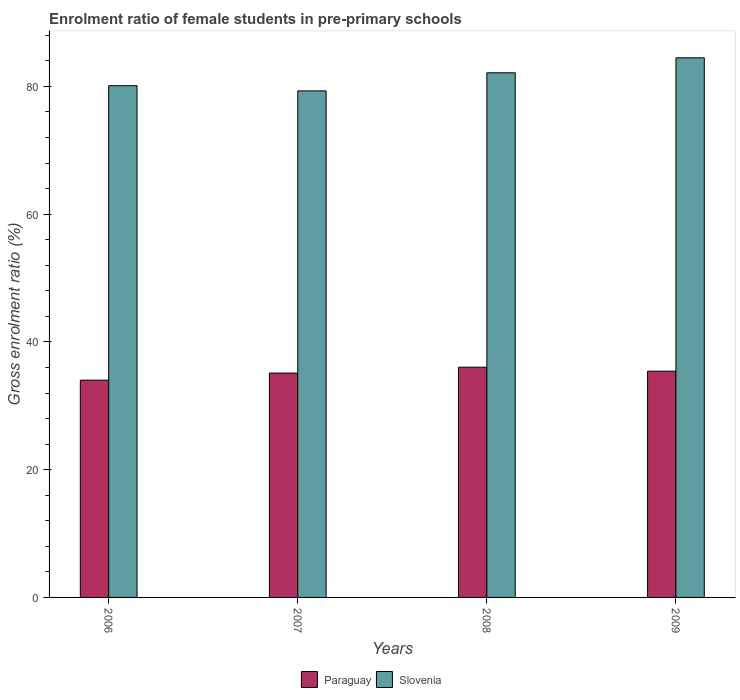How many different coloured bars are there?
Give a very brief answer. 2. Are the number of bars per tick equal to the number of legend labels?
Give a very brief answer. Yes. Are the number of bars on each tick of the X-axis equal?
Provide a short and direct response. Yes. In how many cases, is the number of bars for a given year not equal to the number of legend labels?
Provide a short and direct response. 0. What is the enrolment ratio of female students in pre-primary schools in Slovenia in 2008?
Your answer should be very brief. 82.13. Across all years, what is the maximum enrolment ratio of female students in pre-primary schools in Slovenia?
Your answer should be very brief. 84.48. Across all years, what is the minimum enrolment ratio of female students in pre-primary schools in Paraguay?
Offer a terse response. 34.02. What is the total enrolment ratio of female students in pre-primary schools in Paraguay in the graph?
Keep it short and to the point. 140.6. What is the difference between the enrolment ratio of female students in pre-primary schools in Slovenia in 2007 and that in 2008?
Your answer should be very brief. -2.83. What is the difference between the enrolment ratio of female students in pre-primary schools in Paraguay in 2007 and the enrolment ratio of female students in pre-primary schools in Slovenia in 2006?
Offer a very short reply. -44.99. What is the average enrolment ratio of female students in pre-primary schools in Slovenia per year?
Your response must be concise. 81.51. In the year 2008, what is the difference between the enrolment ratio of female students in pre-primary schools in Slovenia and enrolment ratio of female students in pre-primary schools in Paraguay?
Make the answer very short. 46.09. In how many years, is the enrolment ratio of female students in pre-primary schools in Paraguay greater than 40 %?
Your answer should be compact. 0. What is the ratio of the enrolment ratio of female students in pre-primary schools in Paraguay in 2008 to that in 2009?
Your response must be concise. 1.02. Is the enrolment ratio of female students in pre-primary schools in Slovenia in 2007 less than that in 2009?
Ensure brevity in your answer.  Yes. Is the difference between the enrolment ratio of female students in pre-primary schools in Slovenia in 2006 and 2009 greater than the difference between the enrolment ratio of female students in pre-primary schools in Paraguay in 2006 and 2009?
Offer a terse response. No. What is the difference between the highest and the second highest enrolment ratio of female students in pre-primary schools in Paraguay?
Give a very brief answer. 0.62. What is the difference between the highest and the lowest enrolment ratio of female students in pre-primary schools in Paraguay?
Give a very brief answer. 2.02. What does the 2nd bar from the left in 2009 represents?
Your answer should be very brief. Slovenia. What does the 1st bar from the right in 2006 represents?
Your answer should be very brief. Slovenia. How many bars are there?
Keep it short and to the point. 8. Are all the bars in the graph horizontal?
Ensure brevity in your answer.  No. What is the difference between two consecutive major ticks on the Y-axis?
Offer a very short reply. 20. Are the values on the major ticks of Y-axis written in scientific E-notation?
Make the answer very short. No. Does the graph contain grids?
Ensure brevity in your answer.  No. Where does the legend appear in the graph?
Give a very brief answer. Bottom center. How many legend labels are there?
Your answer should be very brief. 2. How are the legend labels stacked?
Your response must be concise. Horizontal. What is the title of the graph?
Keep it short and to the point. Enrolment ratio of female students in pre-primary schools. Does "Armenia" appear as one of the legend labels in the graph?
Offer a terse response. No. What is the label or title of the X-axis?
Your response must be concise. Years. What is the label or title of the Y-axis?
Offer a terse response. Gross enrolment ratio (%). What is the Gross enrolment ratio (%) in Paraguay in 2006?
Give a very brief answer. 34.02. What is the Gross enrolment ratio (%) in Slovenia in 2006?
Offer a very short reply. 80.11. What is the Gross enrolment ratio (%) in Paraguay in 2007?
Your answer should be very brief. 35.12. What is the Gross enrolment ratio (%) of Slovenia in 2007?
Provide a succinct answer. 79.3. What is the Gross enrolment ratio (%) of Paraguay in 2008?
Your answer should be very brief. 36.04. What is the Gross enrolment ratio (%) in Slovenia in 2008?
Your answer should be very brief. 82.13. What is the Gross enrolment ratio (%) in Paraguay in 2009?
Provide a succinct answer. 35.42. What is the Gross enrolment ratio (%) of Slovenia in 2009?
Your answer should be compact. 84.48. Across all years, what is the maximum Gross enrolment ratio (%) in Paraguay?
Your response must be concise. 36.04. Across all years, what is the maximum Gross enrolment ratio (%) of Slovenia?
Give a very brief answer. 84.48. Across all years, what is the minimum Gross enrolment ratio (%) in Paraguay?
Give a very brief answer. 34.02. Across all years, what is the minimum Gross enrolment ratio (%) of Slovenia?
Give a very brief answer. 79.3. What is the total Gross enrolment ratio (%) in Paraguay in the graph?
Give a very brief answer. 140.6. What is the total Gross enrolment ratio (%) of Slovenia in the graph?
Offer a terse response. 326.02. What is the difference between the Gross enrolment ratio (%) of Paraguay in 2006 and that in 2007?
Your answer should be very brief. -1.11. What is the difference between the Gross enrolment ratio (%) in Slovenia in 2006 and that in 2007?
Ensure brevity in your answer.  0.81. What is the difference between the Gross enrolment ratio (%) of Paraguay in 2006 and that in 2008?
Your answer should be compact. -2.02. What is the difference between the Gross enrolment ratio (%) of Slovenia in 2006 and that in 2008?
Your response must be concise. -2.02. What is the difference between the Gross enrolment ratio (%) of Paraguay in 2006 and that in 2009?
Your answer should be compact. -1.4. What is the difference between the Gross enrolment ratio (%) in Slovenia in 2006 and that in 2009?
Your response must be concise. -4.37. What is the difference between the Gross enrolment ratio (%) in Paraguay in 2007 and that in 2008?
Make the answer very short. -0.92. What is the difference between the Gross enrolment ratio (%) of Slovenia in 2007 and that in 2008?
Your response must be concise. -2.83. What is the difference between the Gross enrolment ratio (%) of Paraguay in 2007 and that in 2009?
Provide a short and direct response. -0.3. What is the difference between the Gross enrolment ratio (%) of Slovenia in 2007 and that in 2009?
Give a very brief answer. -5.18. What is the difference between the Gross enrolment ratio (%) in Paraguay in 2008 and that in 2009?
Your answer should be compact. 0.62. What is the difference between the Gross enrolment ratio (%) in Slovenia in 2008 and that in 2009?
Ensure brevity in your answer.  -2.35. What is the difference between the Gross enrolment ratio (%) in Paraguay in 2006 and the Gross enrolment ratio (%) in Slovenia in 2007?
Give a very brief answer. -45.28. What is the difference between the Gross enrolment ratio (%) in Paraguay in 2006 and the Gross enrolment ratio (%) in Slovenia in 2008?
Keep it short and to the point. -48.12. What is the difference between the Gross enrolment ratio (%) in Paraguay in 2006 and the Gross enrolment ratio (%) in Slovenia in 2009?
Keep it short and to the point. -50.46. What is the difference between the Gross enrolment ratio (%) in Paraguay in 2007 and the Gross enrolment ratio (%) in Slovenia in 2008?
Your answer should be compact. -47.01. What is the difference between the Gross enrolment ratio (%) of Paraguay in 2007 and the Gross enrolment ratio (%) of Slovenia in 2009?
Your answer should be compact. -49.36. What is the difference between the Gross enrolment ratio (%) of Paraguay in 2008 and the Gross enrolment ratio (%) of Slovenia in 2009?
Provide a succinct answer. -48.44. What is the average Gross enrolment ratio (%) of Paraguay per year?
Keep it short and to the point. 35.15. What is the average Gross enrolment ratio (%) in Slovenia per year?
Offer a very short reply. 81.51. In the year 2006, what is the difference between the Gross enrolment ratio (%) of Paraguay and Gross enrolment ratio (%) of Slovenia?
Ensure brevity in your answer.  -46.09. In the year 2007, what is the difference between the Gross enrolment ratio (%) of Paraguay and Gross enrolment ratio (%) of Slovenia?
Offer a terse response. -44.18. In the year 2008, what is the difference between the Gross enrolment ratio (%) of Paraguay and Gross enrolment ratio (%) of Slovenia?
Your answer should be very brief. -46.09. In the year 2009, what is the difference between the Gross enrolment ratio (%) of Paraguay and Gross enrolment ratio (%) of Slovenia?
Provide a succinct answer. -49.06. What is the ratio of the Gross enrolment ratio (%) of Paraguay in 2006 to that in 2007?
Keep it short and to the point. 0.97. What is the ratio of the Gross enrolment ratio (%) in Slovenia in 2006 to that in 2007?
Make the answer very short. 1.01. What is the ratio of the Gross enrolment ratio (%) in Paraguay in 2006 to that in 2008?
Your answer should be very brief. 0.94. What is the ratio of the Gross enrolment ratio (%) of Slovenia in 2006 to that in 2008?
Offer a terse response. 0.98. What is the ratio of the Gross enrolment ratio (%) of Paraguay in 2006 to that in 2009?
Provide a short and direct response. 0.96. What is the ratio of the Gross enrolment ratio (%) in Slovenia in 2006 to that in 2009?
Give a very brief answer. 0.95. What is the ratio of the Gross enrolment ratio (%) of Paraguay in 2007 to that in 2008?
Make the answer very short. 0.97. What is the ratio of the Gross enrolment ratio (%) of Slovenia in 2007 to that in 2008?
Give a very brief answer. 0.97. What is the ratio of the Gross enrolment ratio (%) of Paraguay in 2007 to that in 2009?
Your answer should be very brief. 0.99. What is the ratio of the Gross enrolment ratio (%) of Slovenia in 2007 to that in 2009?
Provide a short and direct response. 0.94. What is the ratio of the Gross enrolment ratio (%) of Paraguay in 2008 to that in 2009?
Give a very brief answer. 1.02. What is the ratio of the Gross enrolment ratio (%) in Slovenia in 2008 to that in 2009?
Your answer should be very brief. 0.97. What is the difference between the highest and the second highest Gross enrolment ratio (%) of Paraguay?
Your answer should be very brief. 0.62. What is the difference between the highest and the second highest Gross enrolment ratio (%) of Slovenia?
Offer a terse response. 2.35. What is the difference between the highest and the lowest Gross enrolment ratio (%) of Paraguay?
Offer a terse response. 2.02. What is the difference between the highest and the lowest Gross enrolment ratio (%) in Slovenia?
Give a very brief answer. 5.18. 